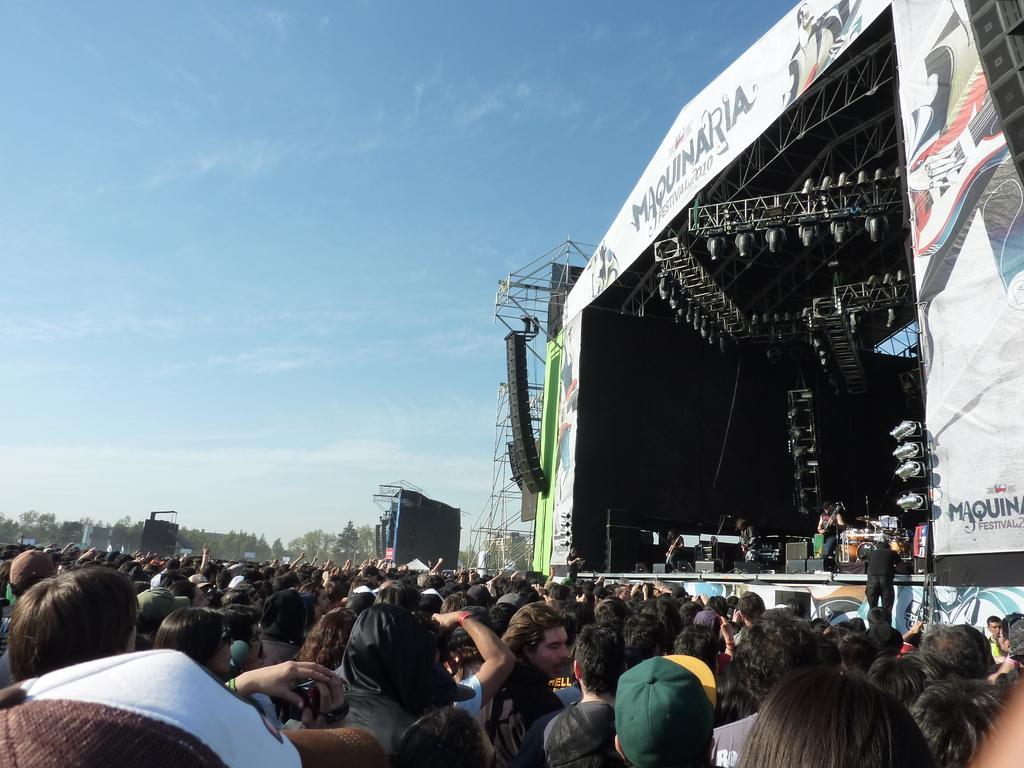How would you summarize this image in a sentence or two? In this image we can see people standing on the ground, electric lights, iron grills, trees, people standing on the dais, musical instruments and sky with clouds in the background. 